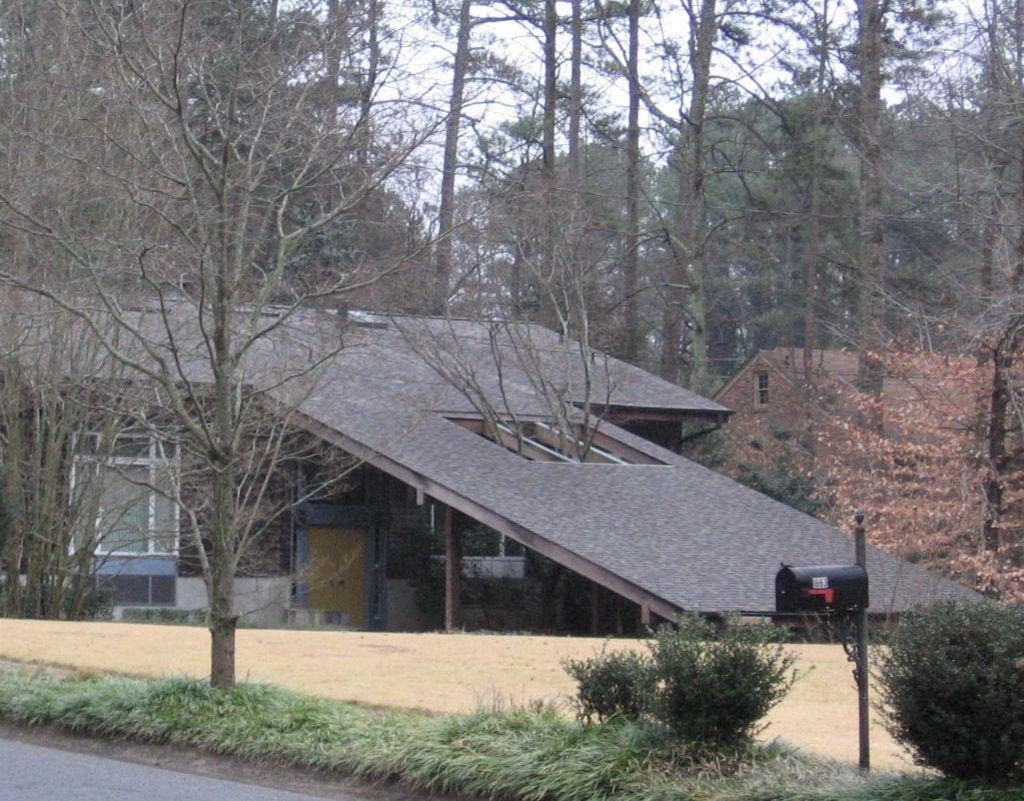What is the main structure in the center of the image? There is a house in the center of the image. What can be seen in the background of the image? The image is filled with trees and plants. What object is attached to a pole at the bottom of the image? There is a pole with a letter box at the bottom of the image. Can you see a loaf of bread being used as a skate in the image? No, there is no loaf of bread or skate present in the image. 